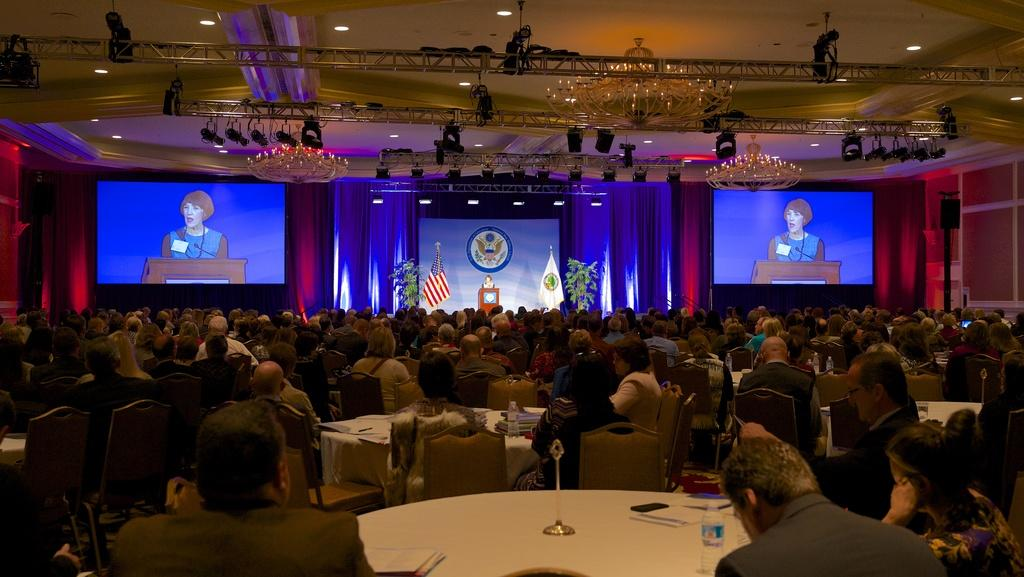Who or what can be seen in the image? There are people in the image. What are the people doing in the image? The people are sitting on chairs. What type of honey is being used to drive the car in the image? There is no car or honey present in the image; it only features people sitting on chairs. 